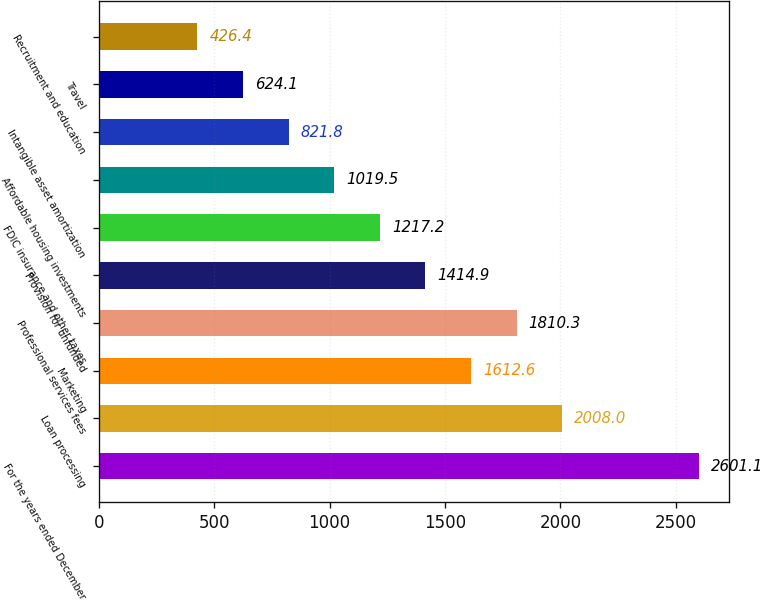Convert chart to OTSL. <chart><loc_0><loc_0><loc_500><loc_500><bar_chart><fcel>For the years ended December<fcel>Loan processing<fcel>Marketing<fcel>Professional services fees<fcel>Provision for unfunded<fcel>FDIC insurance and other taxes<fcel>Affordable housing investments<fcel>Intangible asset amortization<fcel>Travel<fcel>Recruitment and education<nl><fcel>2601.1<fcel>2008<fcel>1612.6<fcel>1810.3<fcel>1414.9<fcel>1217.2<fcel>1019.5<fcel>821.8<fcel>624.1<fcel>426.4<nl></chart> 